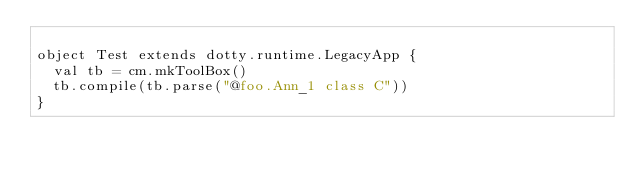<code> <loc_0><loc_0><loc_500><loc_500><_Scala_>
object Test extends dotty.runtime.LegacyApp {
  val tb = cm.mkToolBox()
  tb.compile(tb.parse("@foo.Ann_1 class C"))
}

</code> 